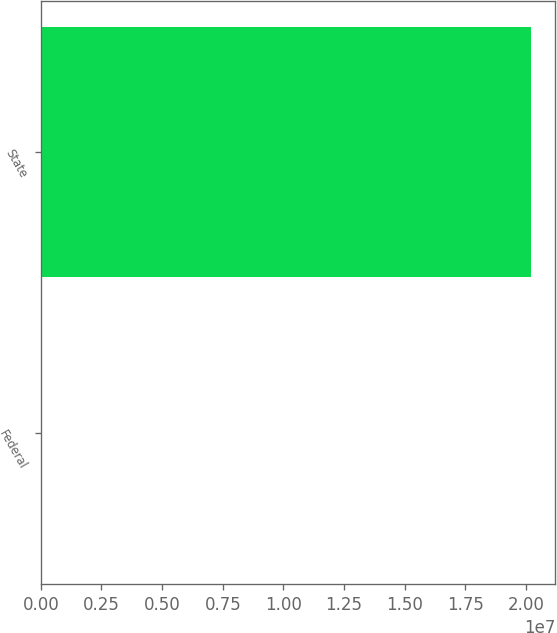Convert chart to OTSL. <chart><loc_0><loc_0><loc_500><loc_500><bar_chart><fcel>Federal<fcel>State<nl><fcel>2032<fcel>2.0192e+07<nl></chart> 